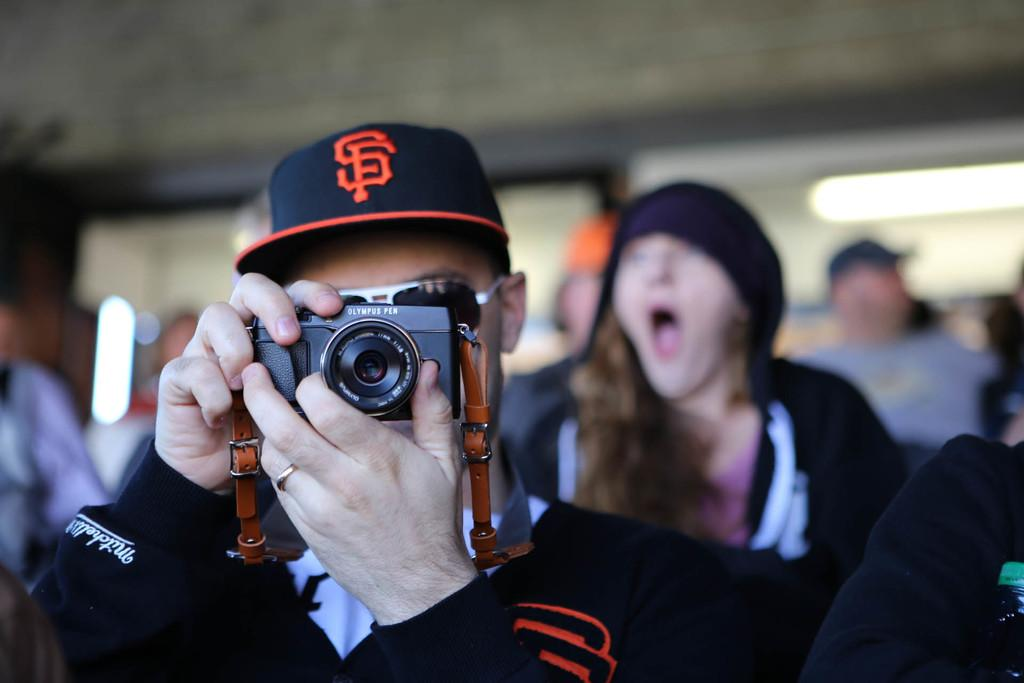Who is the main subject in the image? There is a man in the image. What is the man wearing on his head? The man is wearing a cap. What is the man holding in his hand? The man is holding a camera in his hand. What is the man doing with the camera? The man is taking a picture. What religion is the man practicing in the image? There is no indication of the man's religion in the image. Can you see any mist in the image? There is no mention of mist in the provided facts, and it is not visible in the image. 